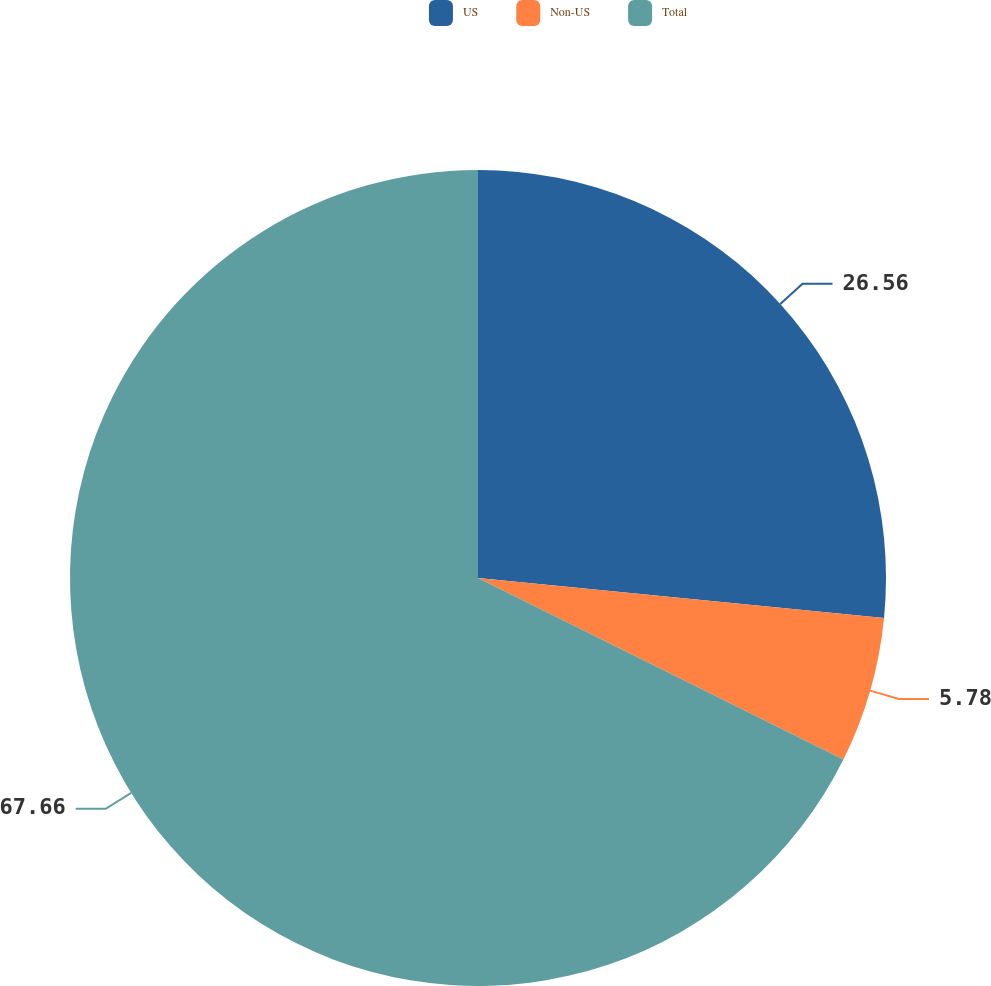Convert chart to OTSL. <chart><loc_0><loc_0><loc_500><loc_500><pie_chart><fcel>US<fcel>Non-US<fcel>Total<nl><fcel>26.56%<fcel>5.78%<fcel>67.66%<nl></chart> 